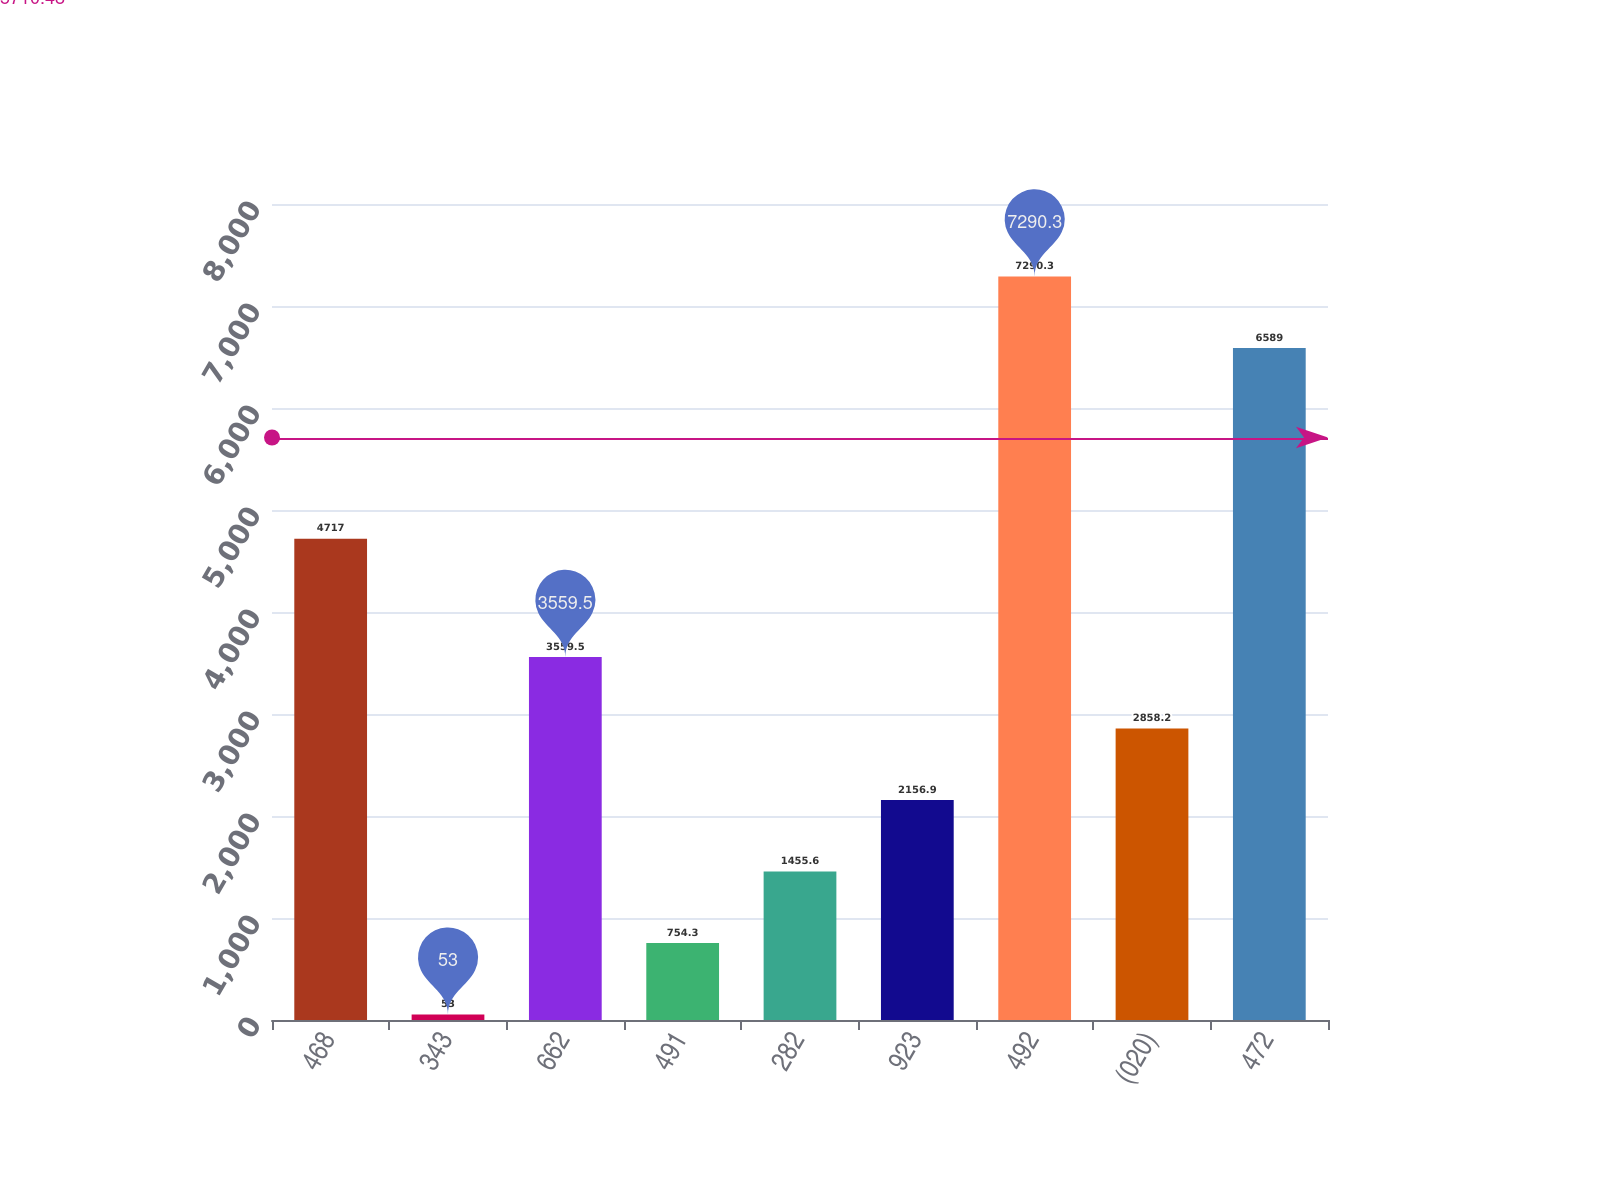Convert chart to OTSL. <chart><loc_0><loc_0><loc_500><loc_500><bar_chart><fcel>468<fcel>343<fcel>662<fcel>491<fcel>282<fcel>923<fcel>492<fcel>(020)<fcel>472<nl><fcel>4717<fcel>53<fcel>3559.5<fcel>754.3<fcel>1455.6<fcel>2156.9<fcel>7290.3<fcel>2858.2<fcel>6589<nl></chart> 